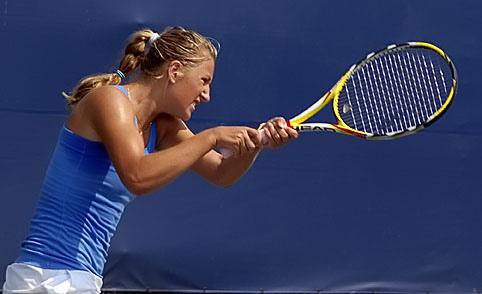What is the name brand of the racket?
Answer briefly. Head. What is on her right arm?
Keep it brief. Nothing. What sport is this lady playing?
Concise answer only. Tennis. How many rackets are there?
Be succinct. 1. 